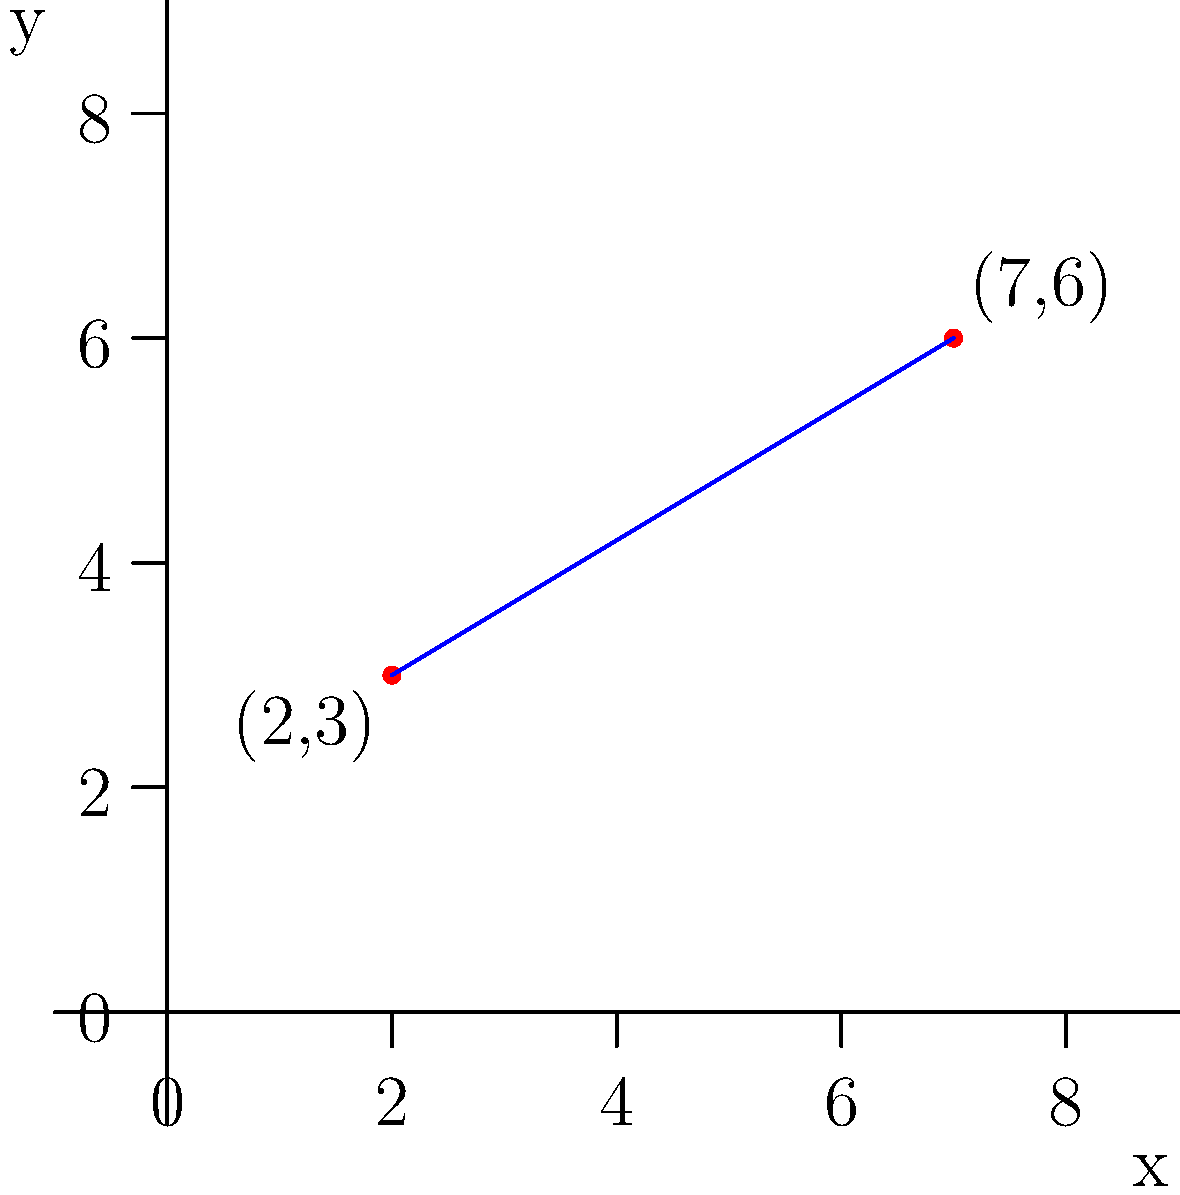You're planning a romantic picnic date at a local park. The park has a coordinate system to help visitors locate amenities. You decide to set up your picnic blanket at point (2,3) and place a surprise gift at point (7,6). To make sure your date can easily find the gift, you want to describe the path between these two points. Calculate the slope of the line passing through these two points to help guide your date to the surprise. Let's approach this step-by-step:

1) The slope formula is:
   $$ m = \frac{y_2 - y_1}{x_2 - x_1} $$
   where $(x_1, y_1)$ is the first point and $(x_2, y_2)$ is the second point.

2) In this case:
   $(x_1, y_1) = (2, 3)$ (picnic blanket location)
   $(x_2, y_2) = (7, 6)$ (surprise gift location)

3) Let's plug these into the formula:
   $$ m = \frac{6 - 3}{7 - 2} $$

4) Simplify:
   $$ m = \frac{3}{5} $$

5) This fraction is already in its simplest form, so this is our final answer.

The slope of $\frac{3}{5}$ means that for every 5 units you move to the right, you move up 3 units. You can use this to guide your date: "For every 5 steps forward, take 3 steps uphill."
Answer: $\frac{3}{5}$ 